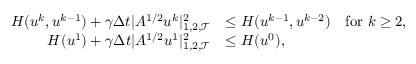Convert formula to latex. <formula><loc_0><loc_0><loc_500><loc_500>\begin{array} { r l } { H ( u ^ { k } , u ^ { k - 1 } ) + \gamma \Delta t | A ^ { 1 / 2 } u ^ { k } | _ { 1 , 2 , { \mathcal { T } } } ^ { 2 } } & { \leq H ( u ^ { k - 1 } , u ^ { k - 2 } ) \quad f o r k \geq 2 , } \\ { H ( u ^ { 1 } ) + \gamma \Delta t | A ^ { 1 / 2 } u ^ { 1 } | _ { 1 , 2 , { \mathcal { T } } } ^ { 2 } } & { \leq H ( u ^ { 0 } ) , } \end{array}</formula> 